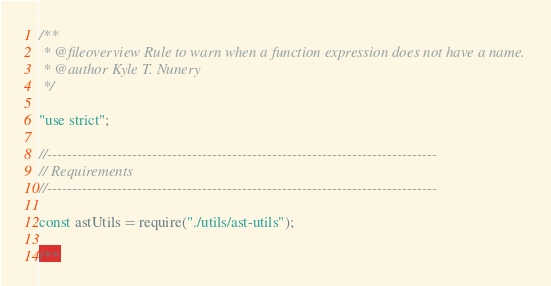Convert code to text. <code><loc_0><loc_0><loc_500><loc_500><_JavaScript_>/**
 * @fileoverview Rule to warn when a function expression does not have a name.
 * @author Kyle T. Nunery
 */

"use strict";

//------------------------------------------------------------------------------
// Requirements
//------------------------------------------------------------------------------

const astUtils = require("./utils/ast-utils");

/**</code> 